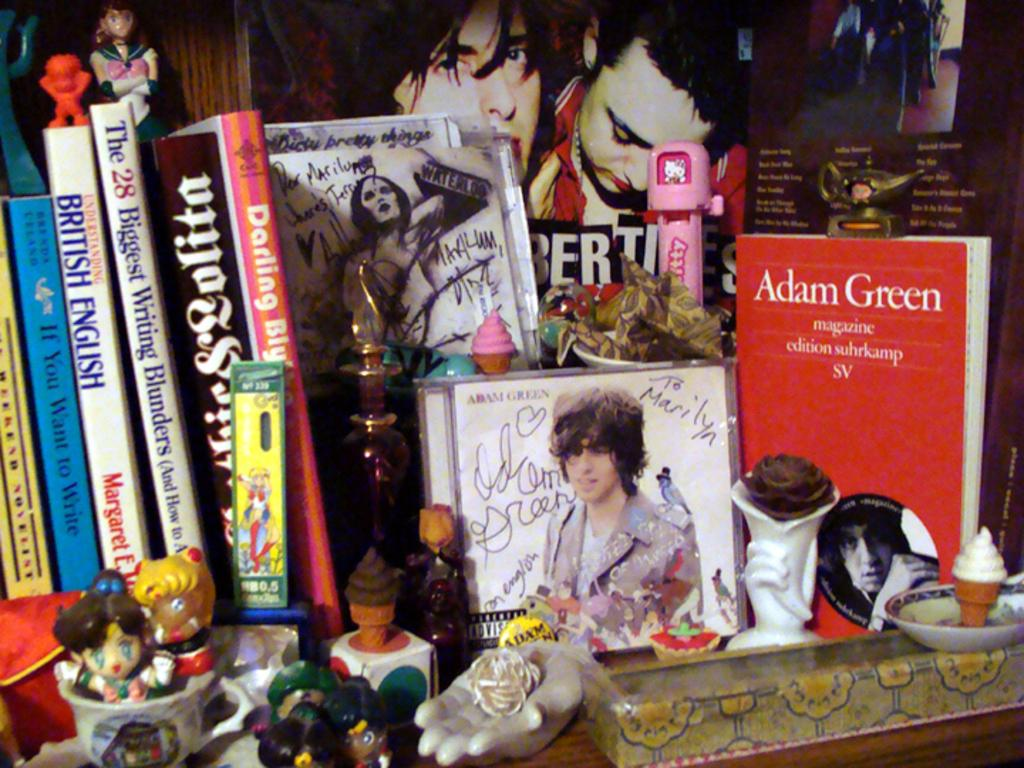Provide a one-sentence caption for the provided image. a red book by Adam Green among other novels with toy figurines. 